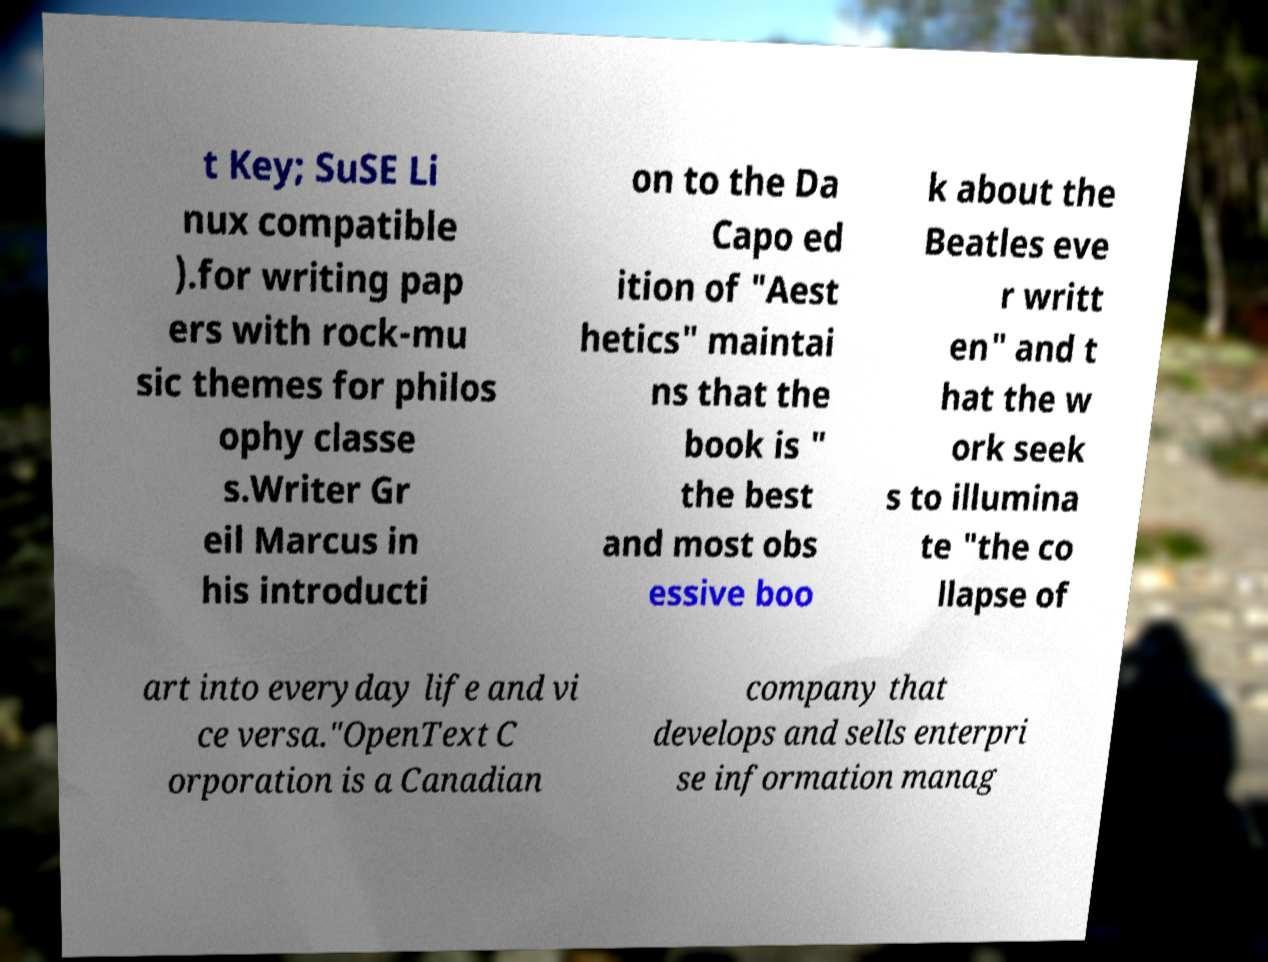What messages or text are displayed in this image? I need them in a readable, typed format. t Key; SuSE Li nux compatible ).for writing pap ers with rock-mu sic themes for philos ophy classe s.Writer Gr eil Marcus in his introducti on to the Da Capo ed ition of "Aest hetics" maintai ns that the book is " the best and most obs essive boo k about the Beatles eve r writt en" and t hat the w ork seek s to illumina te "the co llapse of art into everyday life and vi ce versa."OpenText C orporation is a Canadian company that develops and sells enterpri se information manag 